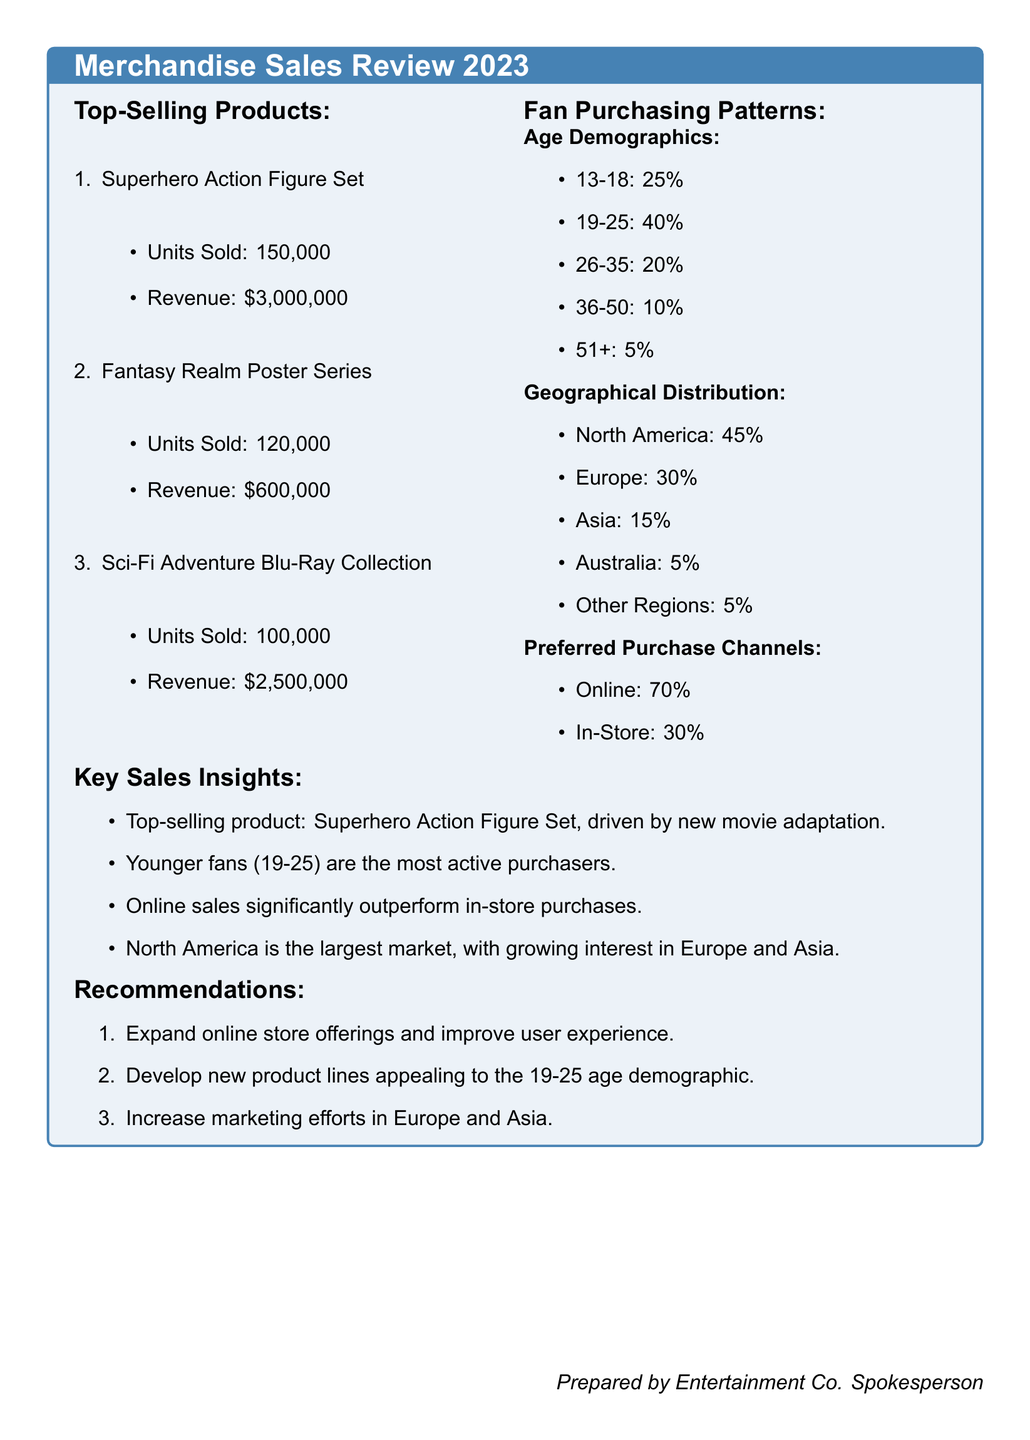what is the top-selling product? The top-selling product listed in the document is the Superhero Action Figure Set.
Answer: Superhero Action Figure Set how many units of the Fantasy Realm Poster Series were sold? The document states that 120,000 units of the Fantasy Realm Poster Series were sold.
Answer: 120,000 what percentage of fans are aged 13-18? According to the document, 25% of fans fall within the 13-18 age demographic.
Answer: 25% how much revenue did the Sci-Fi Adventure Blu-Ray Collection generate? The revenue generated by the Sci-Fi Adventure Blu-Ray Collection is stated to be $2,500,000 in the document.
Answer: $2,500,000 which geographical region has the highest percentage of sales? The document indicates that North America has the highest percentage of sales at 45%.
Answer: North America what is the preferred purchase channel percentage for online sales? The document indicates that 70% of purchases are made online, according to fan purchasing patterns.
Answer: 70% what recommendation is made regarding product lines? The document recommends developing new product lines appealing to the 19-25 age demographic.
Answer: Develop new product lines appealing to the 19-25 age demographic how is the interest in Europe characterized in the sales insights? The sales insight highlights growing interest in Europe as a market for the products.
Answer: Growing interest in Europe what is the total revenue generated from the Superhero Action Figure Set? The total revenue generated from the Superhero Action Figure Set, as stated in the document, is $3,000,000.
Answer: $3,000,000 